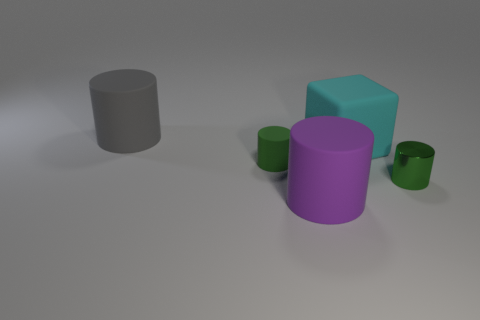Subtract 1 cylinders. How many cylinders are left? 3 Add 1 large purple matte spheres. How many objects exist? 6 Subtract all cubes. How many objects are left? 4 Add 1 shiny things. How many shiny things exist? 2 Subtract 1 gray cylinders. How many objects are left? 4 Subtract all green matte cylinders. Subtract all red cylinders. How many objects are left? 4 Add 3 large purple rubber objects. How many large purple rubber objects are left? 4 